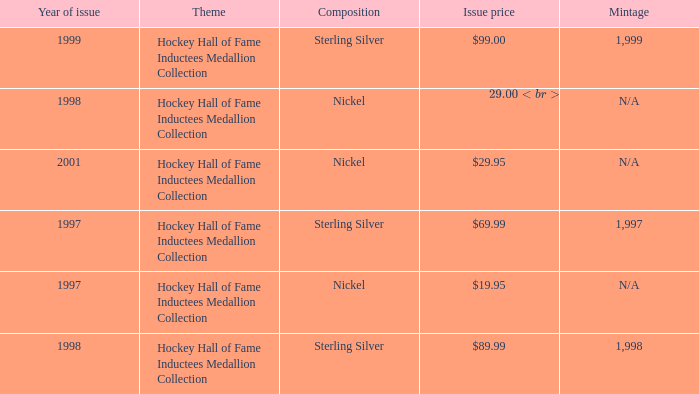How many years was the issue price $19.95? 1.0. 